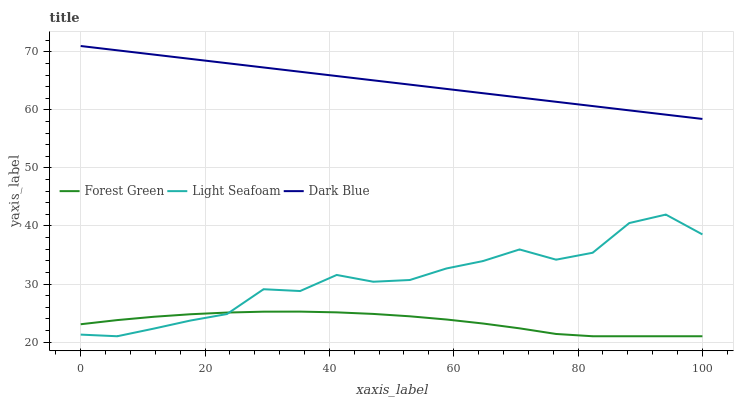Does Forest Green have the minimum area under the curve?
Answer yes or no. Yes. Does Dark Blue have the maximum area under the curve?
Answer yes or no. Yes. Does Light Seafoam have the minimum area under the curve?
Answer yes or no. No. Does Light Seafoam have the maximum area under the curve?
Answer yes or no. No. Is Dark Blue the smoothest?
Answer yes or no. Yes. Is Light Seafoam the roughest?
Answer yes or no. Yes. Is Forest Green the smoothest?
Answer yes or no. No. Is Forest Green the roughest?
Answer yes or no. No. Does Forest Green have the lowest value?
Answer yes or no. Yes. Does Dark Blue have the highest value?
Answer yes or no. Yes. Does Light Seafoam have the highest value?
Answer yes or no. No. Is Light Seafoam less than Dark Blue?
Answer yes or no. Yes. Is Dark Blue greater than Forest Green?
Answer yes or no. Yes. Does Light Seafoam intersect Forest Green?
Answer yes or no. Yes. Is Light Seafoam less than Forest Green?
Answer yes or no. No. Is Light Seafoam greater than Forest Green?
Answer yes or no. No. Does Light Seafoam intersect Dark Blue?
Answer yes or no. No. 